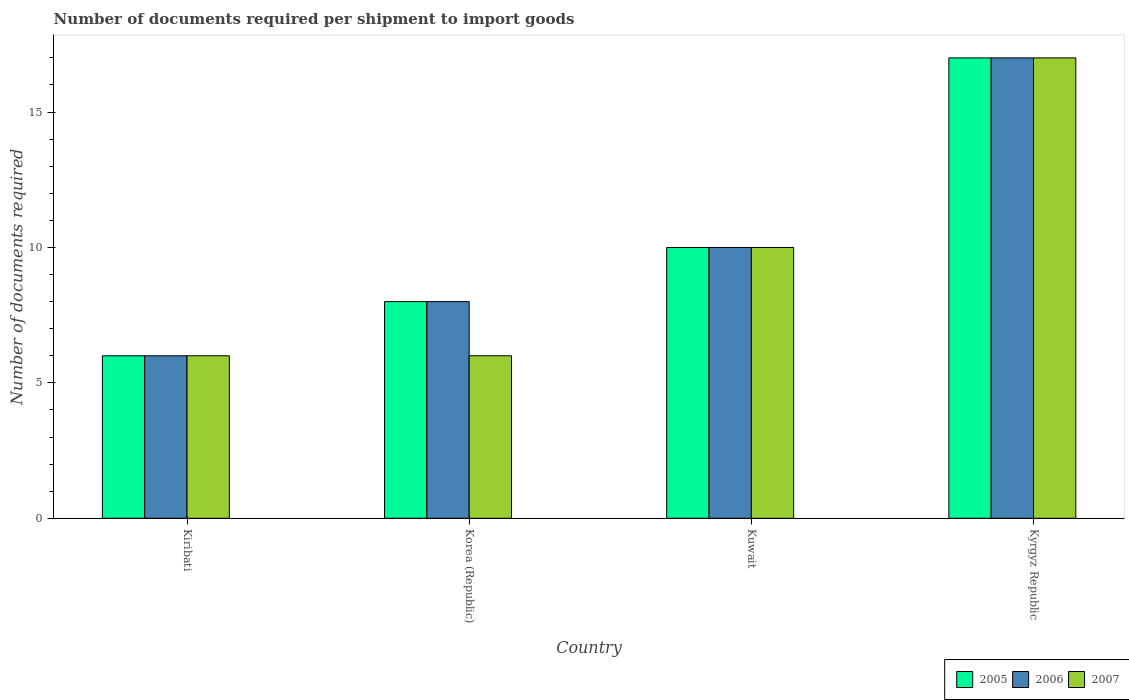How many different coloured bars are there?
Your response must be concise. 3. How many bars are there on the 2nd tick from the left?
Keep it short and to the point. 3. What is the label of the 3rd group of bars from the left?
Ensure brevity in your answer.  Kuwait. In how many cases, is the number of bars for a given country not equal to the number of legend labels?
Give a very brief answer. 0. What is the number of documents required per shipment to import goods in 2007 in Kiribati?
Offer a terse response. 6. Across all countries, what is the maximum number of documents required per shipment to import goods in 2006?
Your answer should be compact. 17. Across all countries, what is the minimum number of documents required per shipment to import goods in 2007?
Your answer should be very brief. 6. In which country was the number of documents required per shipment to import goods in 2006 maximum?
Your answer should be compact. Kyrgyz Republic. In which country was the number of documents required per shipment to import goods in 2007 minimum?
Offer a very short reply. Kiribati. What is the average number of documents required per shipment to import goods in 2007 per country?
Provide a short and direct response. 9.75. What is the difference between the number of documents required per shipment to import goods of/in 2007 and number of documents required per shipment to import goods of/in 2005 in Korea (Republic)?
Your answer should be very brief. -2. In how many countries, is the number of documents required per shipment to import goods in 2007 greater than 9?
Your answer should be very brief. 2. What is the ratio of the number of documents required per shipment to import goods in 2005 in Korea (Republic) to that in Kuwait?
Your response must be concise. 0.8. In how many countries, is the number of documents required per shipment to import goods in 2007 greater than the average number of documents required per shipment to import goods in 2007 taken over all countries?
Your answer should be very brief. 2. What does the 3rd bar from the left in Kuwait represents?
Your answer should be compact. 2007. How many countries are there in the graph?
Your response must be concise. 4. What is the difference between two consecutive major ticks on the Y-axis?
Offer a terse response. 5. Does the graph contain grids?
Your response must be concise. No. How many legend labels are there?
Your response must be concise. 3. How are the legend labels stacked?
Offer a very short reply. Horizontal. What is the title of the graph?
Offer a very short reply. Number of documents required per shipment to import goods. What is the label or title of the Y-axis?
Your answer should be very brief. Number of documents required. What is the Number of documents required of 2005 in Kiribati?
Give a very brief answer. 6. What is the Number of documents required of 2006 in Kiribati?
Provide a succinct answer. 6. What is the Number of documents required of 2006 in Korea (Republic)?
Provide a succinct answer. 8. What is the Number of documents required in 2005 in Kuwait?
Your answer should be compact. 10. What is the Number of documents required in 2007 in Kuwait?
Make the answer very short. 10. What is the Number of documents required in 2006 in Kyrgyz Republic?
Offer a terse response. 17. Across all countries, what is the maximum Number of documents required of 2005?
Ensure brevity in your answer.  17. Across all countries, what is the minimum Number of documents required of 2005?
Your answer should be compact. 6. Across all countries, what is the minimum Number of documents required of 2007?
Your response must be concise. 6. What is the total Number of documents required in 2005 in the graph?
Offer a very short reply. 41. What is the difference between the Number of documents required of 2005 in Kiribati and that in Korea (Republic)?
Offer a terse response. -2. What is the difference between the Number of documents required in 2007 in Kiribati and that in Korea (Republic)?
Keep it short and to the point. 0. What is the difference between the Number of documents required in 2005 in Kiribati and that in Kuwait?
Keep it short and to the point. -4. What is the difference between the Number of documents required of 2006 in Kiribati and that in Kuwait?
Your answer should be very brief. -4. What is the difference between the Number of documents required of 2007 in Kiribati and that in Kuwait?
Your answer should be compact. -4. What is the difference between the Number of documents required in 2007 in Kiribati and that in Kyrgyz Republic?
Offer a very short reply. -11. What is the difference between the Number of documents required in 2005 in Korea (Republic) and that in Kuwait?
Give a very brief answer. -2. What is the difference between the Number of documents required in 2006 in Korea (Republic) and that in Kuwait?
Offer a terse response. -2. What is the difference between the Number of documents required in 2006 in Kuwait and that in Kyrgyz Republic?
Provide a succinct answer. -7. What is the difference between the Number of documents required of 2005 in Kiribati and the Number of documents required of 2007 in Korea (Republic)?
Ensure brevity in your answer.  0. What is the difference between the Number of documents required in 2006 in Kiribati and the Number of documents required in 2007 in Korea (Republic)?
Keep it short and to the point. 0. What is the difference between the Number of documents required in 2005 in Kiribati and the Number of documents required in 2007 in Kuwait?
Ensure brevity in your answer.  -4. What is the difference between the Number of documents required in 2005 in Kiribati and the Number of documents required in 2006 in Kyrgyz Republic?
Provide a succinct answer. -11. What is the difference between the Number of documents required of 2005 in Korea (Republic) and the Number of documents required of 2006 in Kuwait?
Provide a succinct answer. -2. What is the difference between the Number of documents required of 2005 in Korea (Republic) and the Number of documents required of 2007 in Kuwait?
Your answer should be compact. -2. What is the difference between the Number of documents required in 2005 in Korea (Republic) and the Number of documents required in 2007 in Kyrgyz Republic?
Give a very brief answer. -9. What is the difference between the Number of documents required in 2006 in Korea (Republic) and the Number of documents required in 2007 in Kyrgyz Republic?
Your answer should be very brief. -9. What is the difference between the Number of documents required in 2005 in Kuwait and the Number of documents required in 2007 in Kyrgyz Republic?
Your response must be concise. -7. What is the difference between the Number of documents required in 2006 in Kuwait and the Number of documents required in 2007 in Kyrgyz Republic?
Your response must be concise. -7. What is the average Number of documents required of 2005 per country?
Offer a very short reply. 10.25. What is the average Number of documents required in 2006 per country?
Keep it short and to the point. 10.25. What is the average Number of documents required of 2007 per country?
Offer a terse response. 9.75. What is the difference between the Number of documents required of 2005 and Number of documents required of 2007 in Kiribati?
Provide a short and direct response. 0. What is the difference between the Number of documents required of 2005 and Number of documents required of 2007 in Kuwait?
Provide a succinct answer. 0. What is the difference between the Number of documents required in 2006 and Number of documents required in 2007 in Kuwait?
Offer a terse response. 0. What is the difference between the Number of documents required in 2005 and Number of documents required in 2007 in Kyrgyz Republic?
Provide a succinct answer. 0. What is the ratio of the Number of documents required of 2005 in Kiribati to that in Kuwait?
Keep it short and to the point. 0.6. What is the ratio of the Number of documents required of 2005 in Kiribati to that in Kyrgyz Republic?
Provide a succinct answer. 0.35. What is the ratio of the Number of documents required of 2006 in Kiribati to that in Kyrgyz Republic?
Your answer should be very brief. 0.35. What is the ratio of the Number of documents required in 2007 in Kiribati to that in Kyrgyz Republic?
Provide a short and direct response. 0.35. What is the ratio of the Number of documents required of 2005 in Korea (Republic) to that in Kyrgyz Republic?
Provide a short and direct response. 0.47. What is the ratio of the Number of documents required in 2006 in Korea (Republic) to that in Kyrgyz Republic?
Your answer should be compact. 0.47. What is the ratio of the Number of documents required of 2007 in Korea (Republic) to that in Kyrgyz Republic?
Ensure brevity in your answer.  0.35. What is the ratio of the Number of documents required of 2005 in Kuwait to that in Kyrgyz Republic?
Provide a succinct answer. 0.59. What is the ratio of the Number of documents required in 2006 in Kuwait to that in Kyrgyz Republic?
Your answer should be compact. 0.59. What is the ratio of the Number of documents required in 2007 in Kuwait to that in Kyrgyz Republic?
Provide a succinct answer. 0.59. What is the difference between the highest and the second highest Number of documents required in 2006?
Your answer should be compact. 7. What is the difference between the highest and the second highest Number of documents required of 2007?
Keep it short and to the point. 7. What is the difference between the highest and the lowest Number of documents required of 2006?
Provide a succinct answer. 11. 